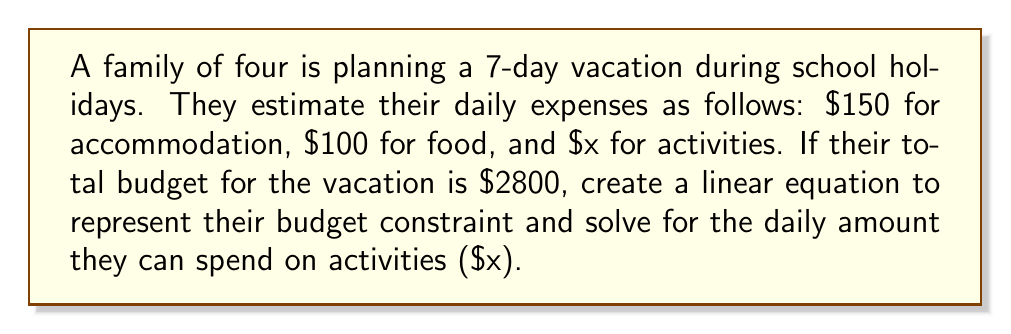Solve this math problem. Let's approach this step-by-step:

1) First, let's identify the known variables:
   - Number of days: 7
   - Daily accommodation cost: $150
   - Daily food cost: $100
   - Total budget: $2800
   - Daily activities cost: $x (unknown)

2) Now, let's create a linear equation to represent the budget constraint:
   $$(150 + 100 + x) \cdot 7 = 2800$$

3) Let's simplify the left side of the equation:
   $$(250 + x) \cdot 7 = 2800$$
   $$1750 + 7x = 2800$$

4) Subtract 1750 from both sides:
   $$7x = 2800 - 1750 = 1050$$

5) Divide both sides by 7:
   $$x = \frac{1050}{7} = 150$$

Therefore, the family can spend $150 per day on activities.
Answer: $150 